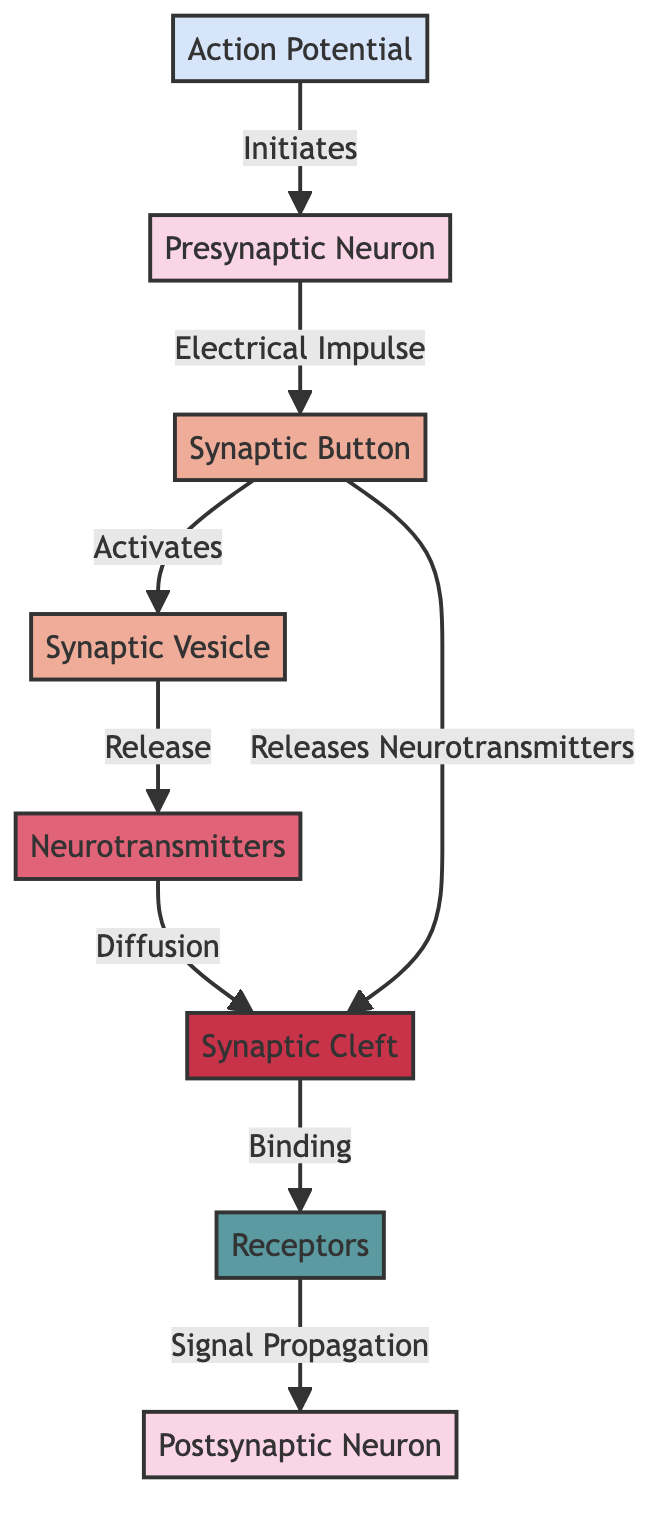What is the first step in the synaptic transmission process? The first step is the initiation of the action potential, indicated by the arrow pointing from 'Action Potential' to 'Presynaptic Neuron'. This shows that the action potential triggers further processes.
Answer: Initiates How many neurotransmitters are involved in this diagram? The diagram indicates that neurotransmitters are released from the 'Synaptic Vesicle', but it does not specify a numerical value. Thus, we refer to the general term.
Answer: Neurotransmitters What role does the synaptic cleft play in neurotransmission? The synaptic cleft serves as a space where neurotransmitters diffuse after release, as shown by the directed arrow from 'Neurotransmitters' to 'Synaptic Cleft'. This explains its role in communication between neurons.
Answer: Diffusion What happens after the synaptic vesicle releases neurotransmitters? After the release, the neurotransmitters diffuse across the synaptic cleft, as shown by the arrow leading from 'Neurotransmitters' to 'Synaptic Cleft'. This step is crucial for proper signal transmission to the postsynaptic neuron.
Answer: Binding Which node indicates signal propagation to the postsynaptic neuron? The node 'Receptors' indicates the binding of neurotransmitters that leads to signal propagation to the 'Postsynaptic Neuron', as shown by the arrow leading from 'Receptors' to 'Postsynaptic Neuron'.
Answer: Signal Propagation 